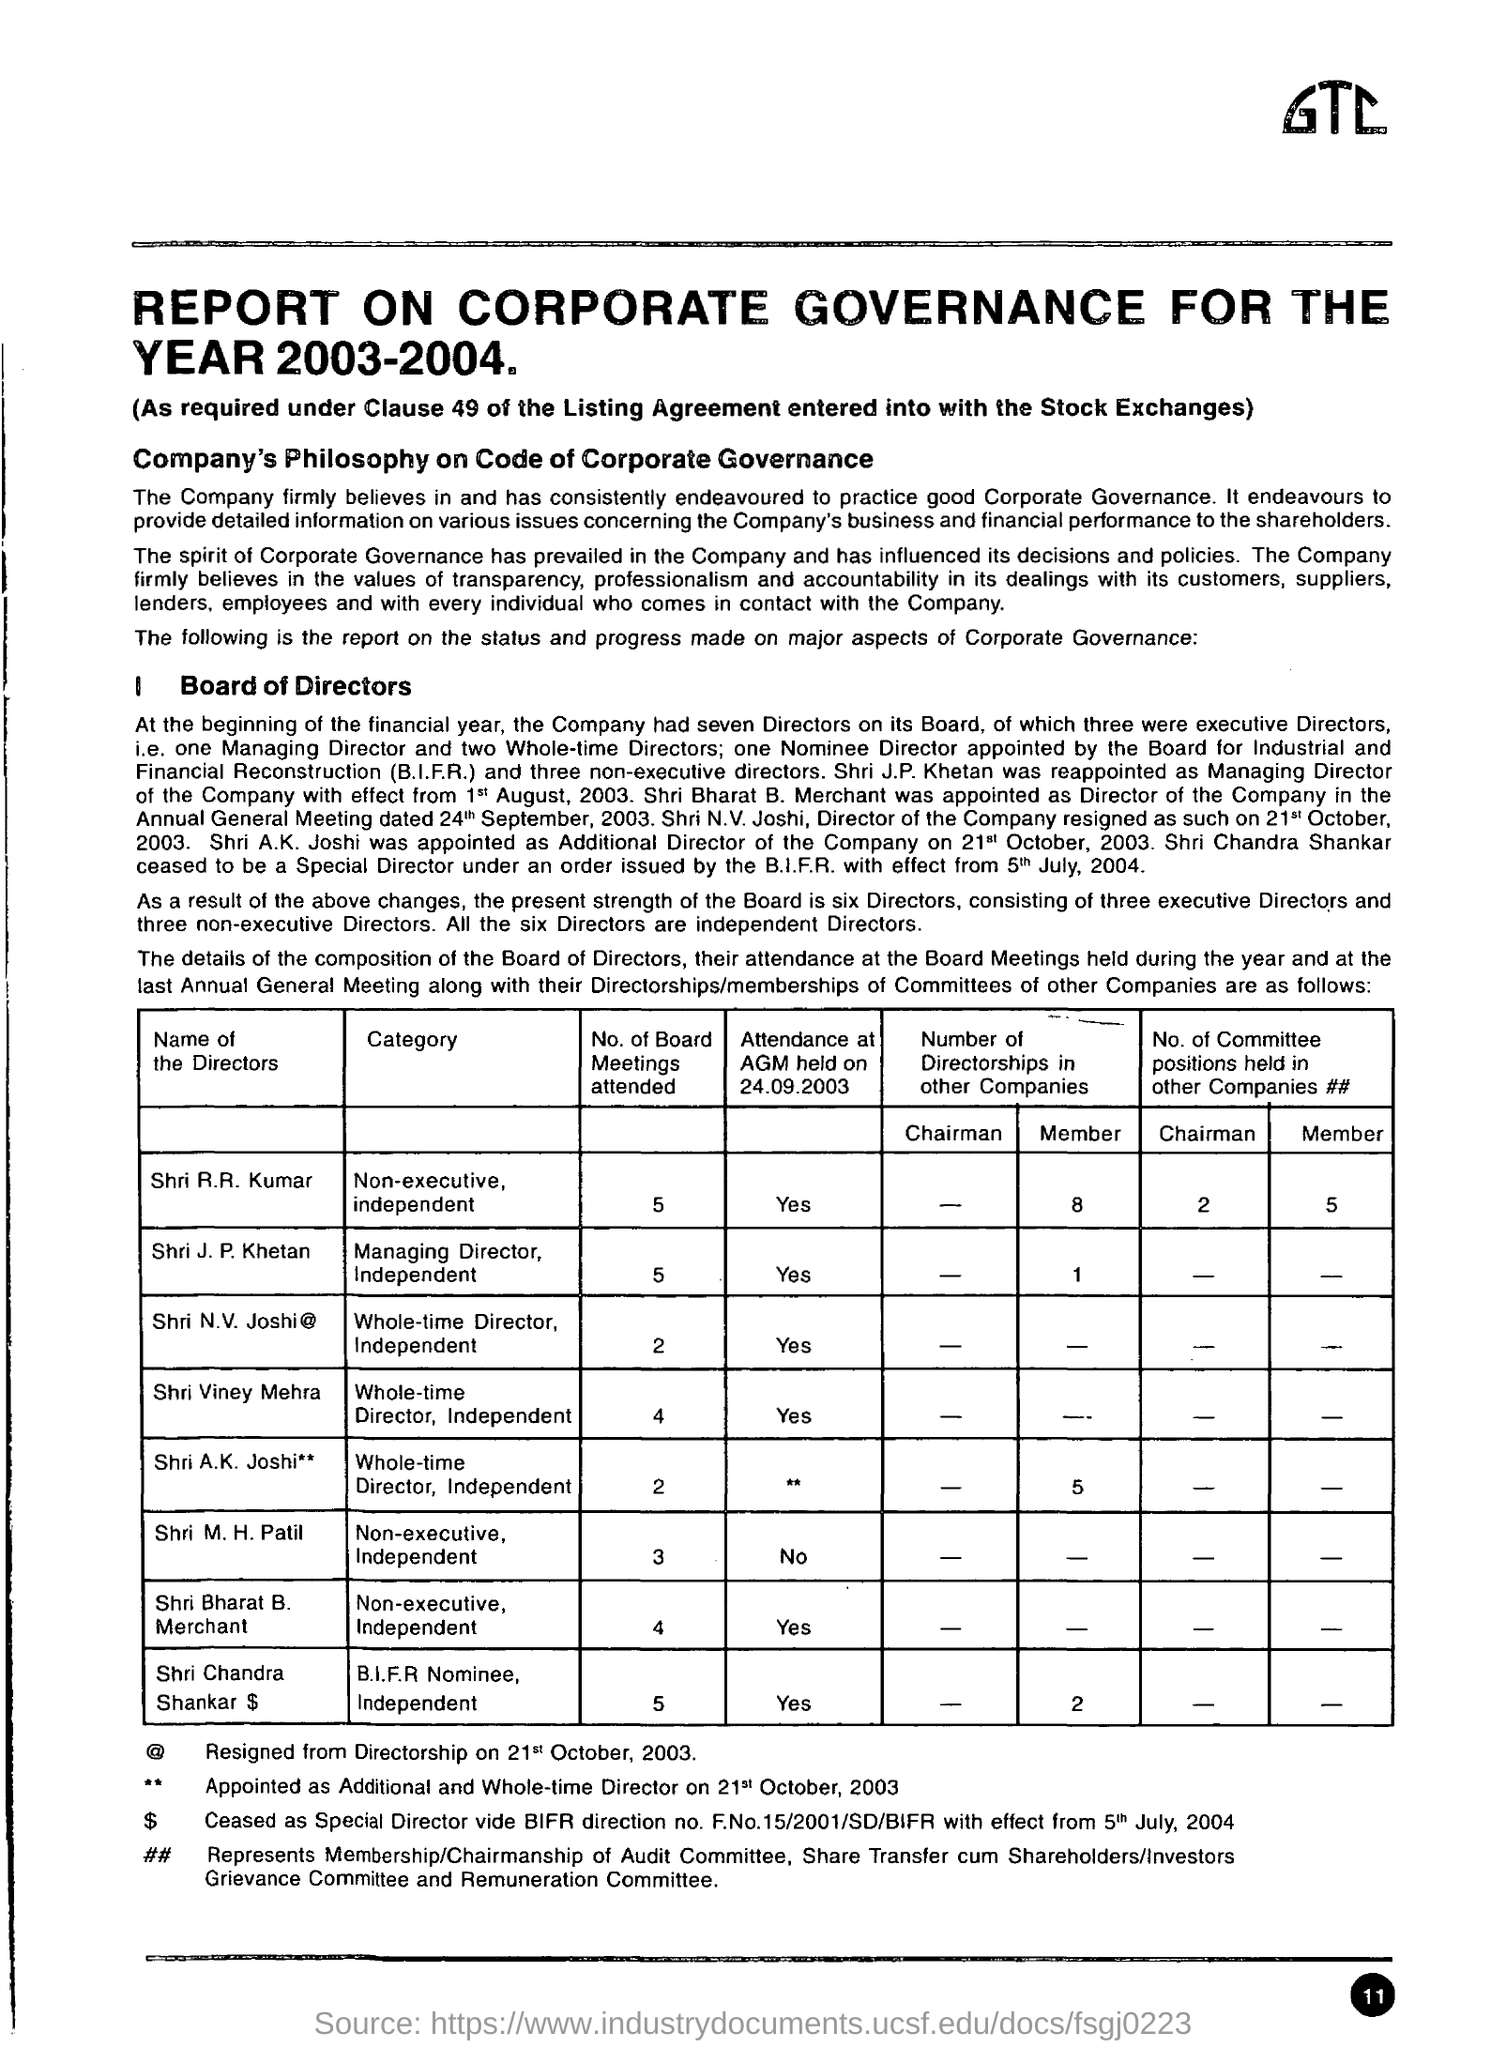What additional roles did these directors have outside the company? The directors held multiple positions in other companies, which is a common practice to bring diverse experience to the board. For instance, Shri R.R. Kumar was a chairman of one other company and a member of committees in five other companies, showing a broad range of influence and responsibilities. 